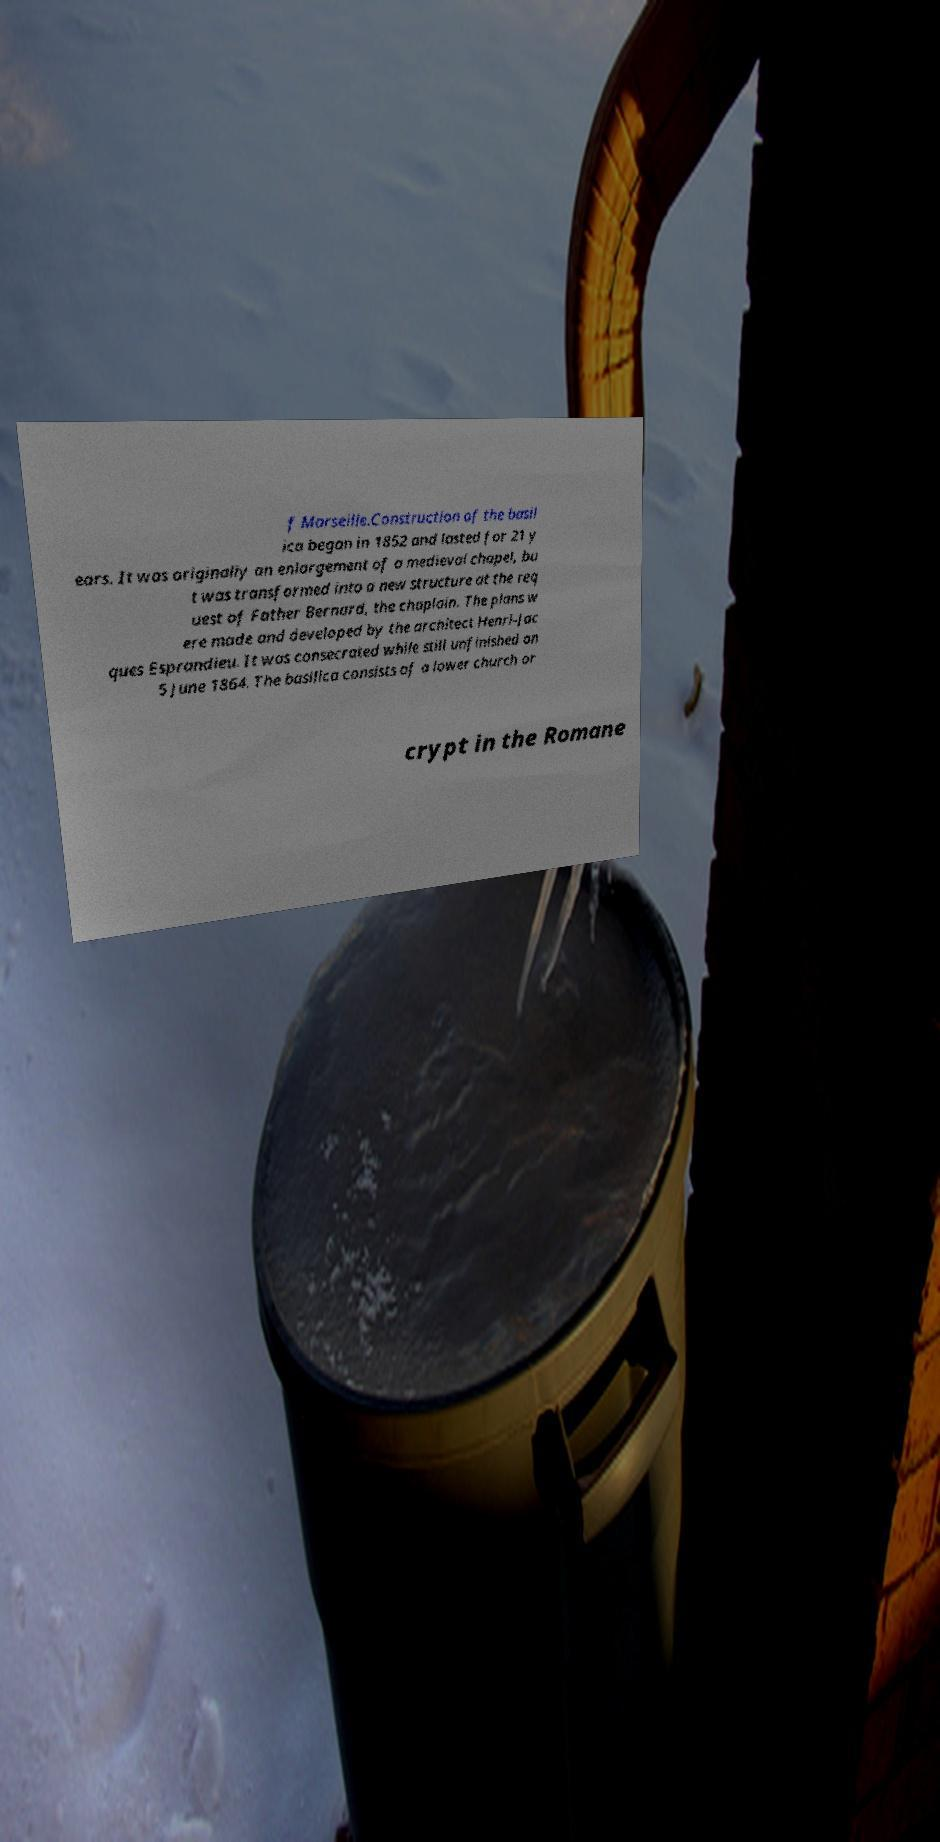Please read and relay the text visible in this image. What does it say? f Marseille.Construction of the basil ica began in 1852 and lasted for 21 y ears. It was originally an enlargement of a medieval chapel, bu t was transformed into a new structure at the req uest of Father Bernard, the chaplain. The plans w ere made and developed by the architect Henri-Jac ques Esprandieu. It was consecrated while still unfinished on 5 June 1864. The basilica consists of a lower church or crypt in the Romane 